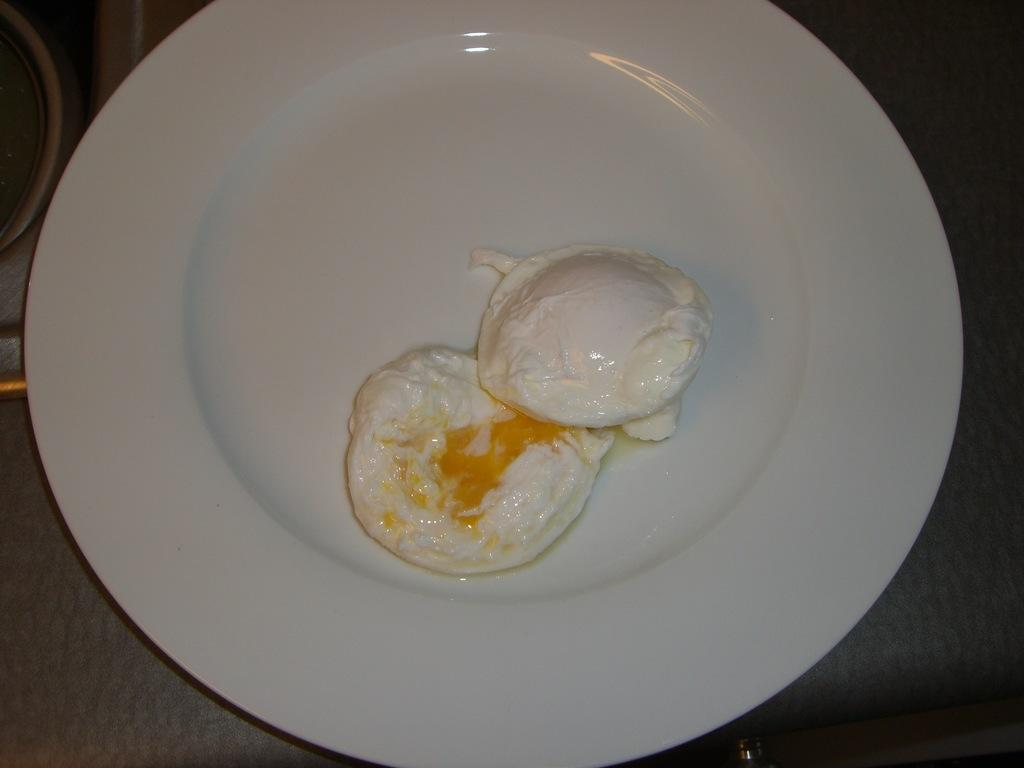What is the main subject of the image? There is a food item in the image. How is the food item presented? The food item is on a white color plate. What is the color of the surface beneath the plate? The plate is on a dark color surface. What type of prose can be seen on the plate in the image? There is no prose present on the plate in the image; it is a food item on a white color plate. Can you tell me how many frogs are sitting on the dark color surface in the image? There are no frogs present in the image; it features a food item on a white color plate on a dark color surface. 